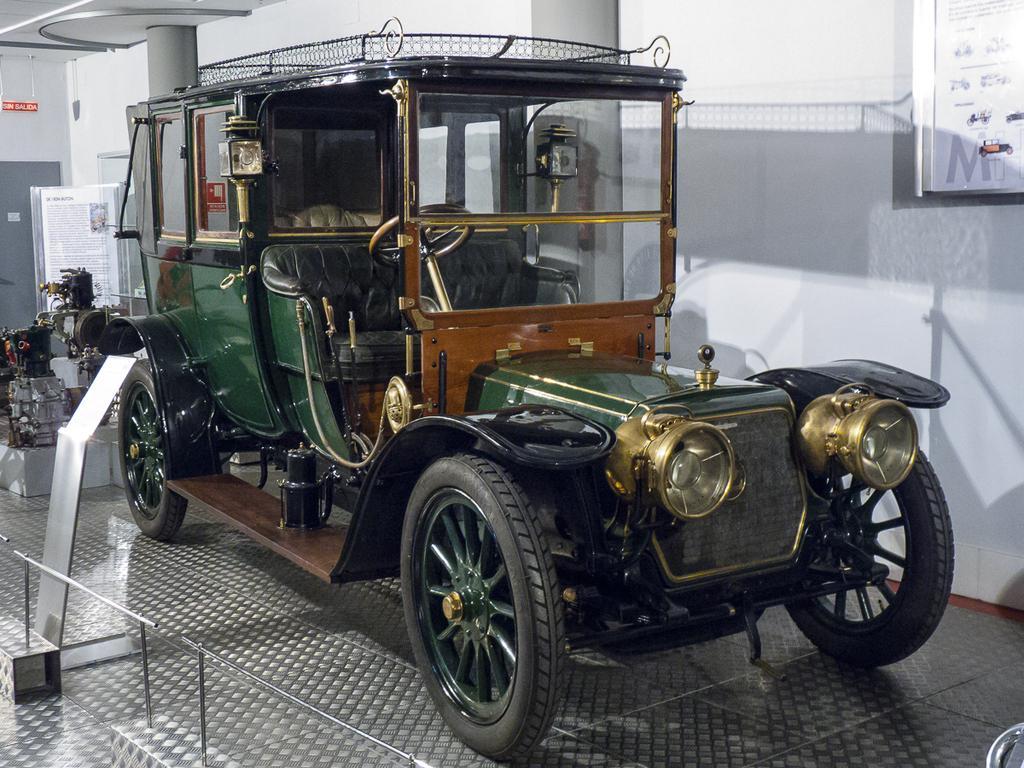Describe this image in one or two sentences. In this picture I can see a vehicle in front and it is on the floor. In the background I see the wall and 2 pillars and on the left side of this image I see an equipment. 